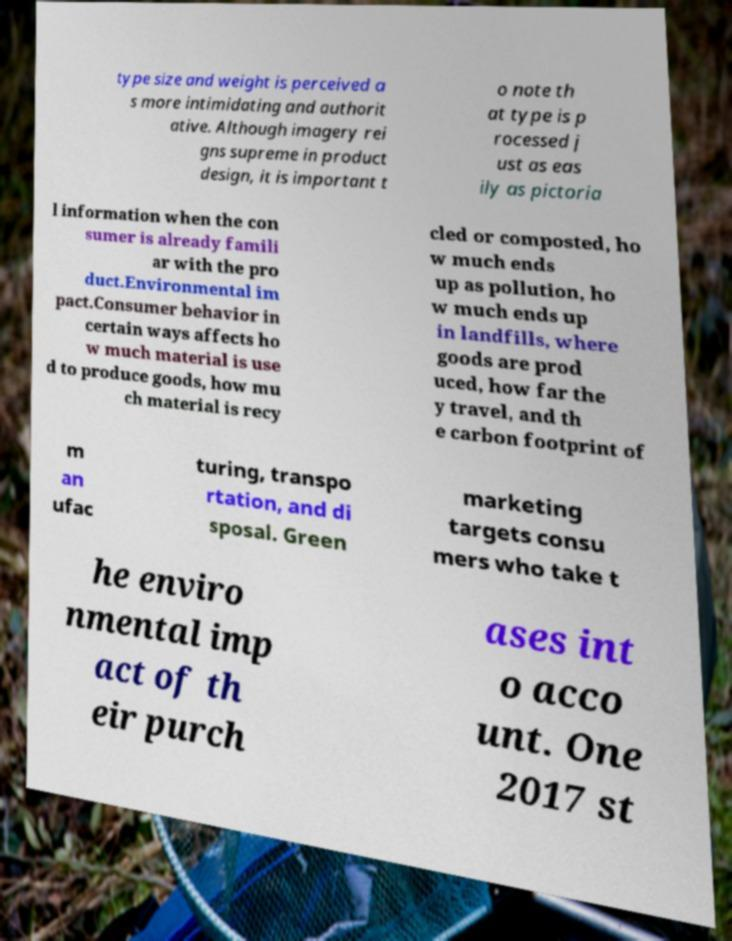Please read and relay the text visible in this image. What does it say? type size and weight is perceived a s more intimidating and authorit ative. Although imagery rei gns supreme in product design, it is important t o note th at type is p rocessed j ust as eas ily as pictoria l information when the con sumer is already famili ar with the pro duct.Environmental im pact.Consumer behavior in certain ways affects ho w much material is use d to produce goods, how mu ch material is recy cled or composted, ho w much ends up as pollution, ho w much ends up in landfills, where goods are prod uced, how far the y travel, and th e carbon footprint of m an ufac turing, transpo rtation, and di sposal. Green marketing targets consu mers who take t he enviro nmental imp act of th eir purch ases int o acco unt. One 2017 st 